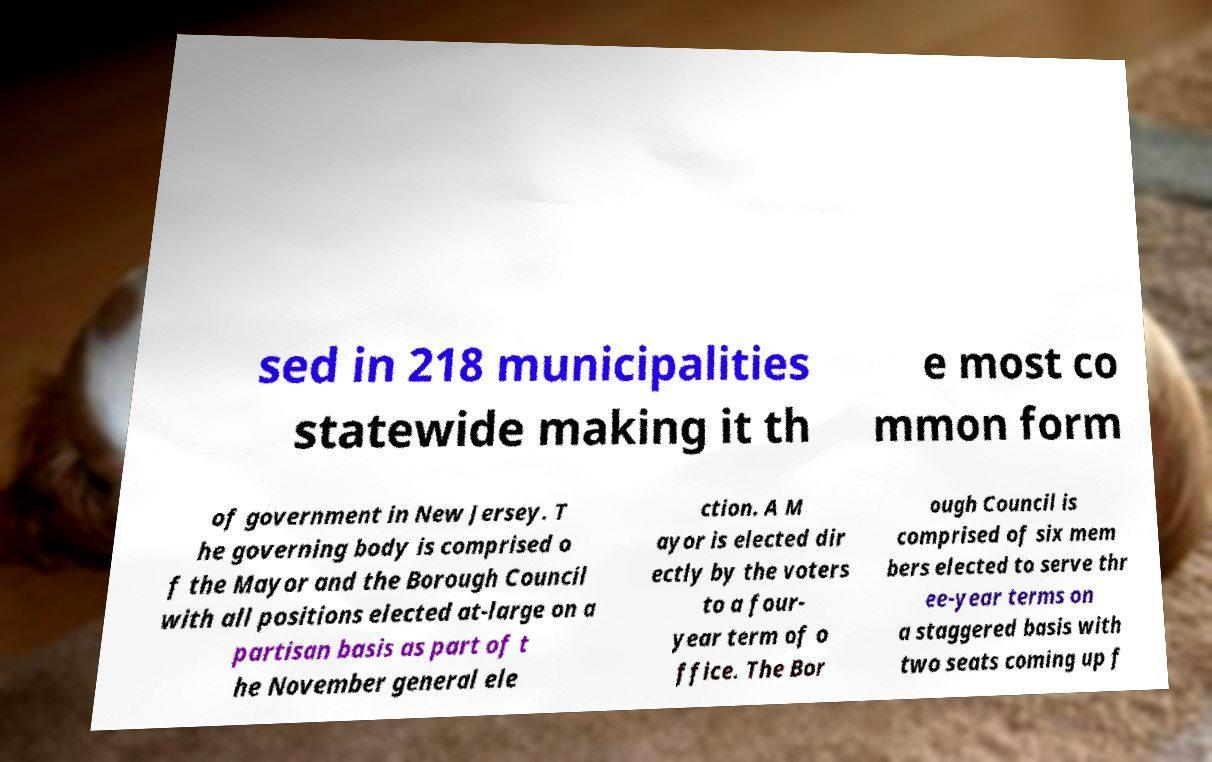For documentation purposes, I need the text within this image transcribed. Could you provide that? sed in 218 municipalities statewide making it th e most co mmon form of government in New Jersey. T he governing body is comprised o f the Mayor and the Borough Council with all positions elected at-large on a partisan basis as part of t he November general ele ction. A M ayor is elected dir ectly by the voters to a four- year term of o ffice. The Bor ough Council is comprised of six mem bers elected to serve thr ee-year terms on a staggered basis with two seats coming up f 